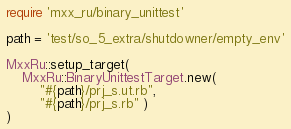Convert code to text. <code><loc_0><loc_0><loc_500><loc_500><_Ruby_>require 'mxx_ru/binary_unittest'

path = 'test/so_5_extra/shutdowner/empty_env'

MxxRu::setup_target(
	MxxRu::BinaryUnittestTarget.new(
		"#{path}/prj_s.ut.rb",
		"#{path}/prj_s.rb" )
)
</code> 